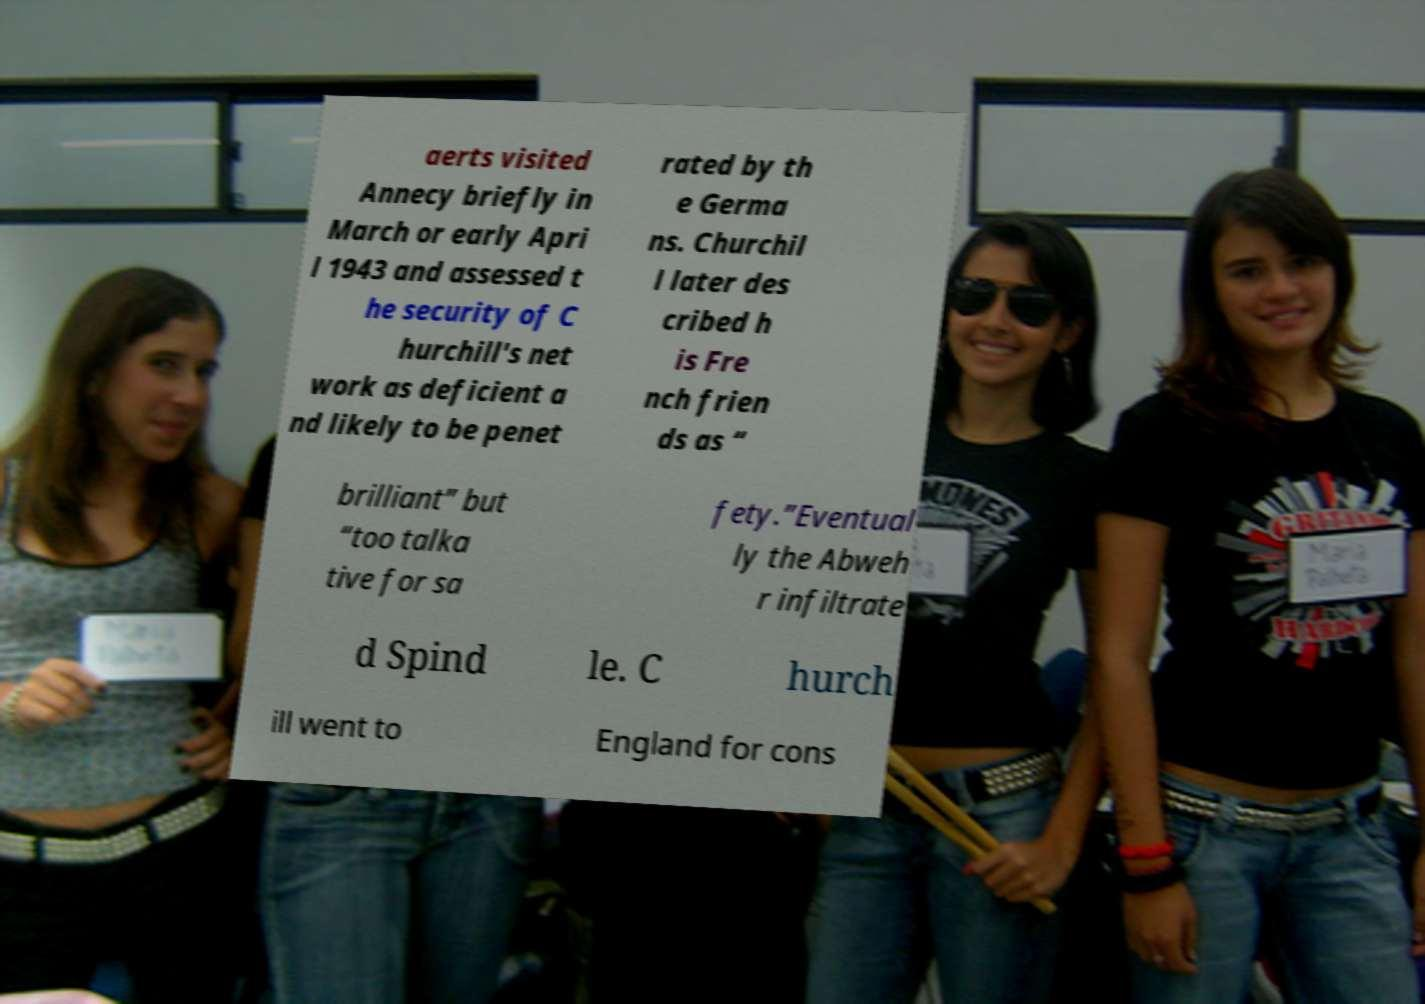What messages or text are displayed in this image? I need them in a readable, typed format. aerts visited Annecy briefly in March or early Apri l 1943 and assessed t he security of C hurchill's net work as deficient a nd likely to be penet rated by th e Germa ns. Churchil l later des cribed h is Fre nch frien ds as “ brilliant” but “too talka tive for sa fety.”Eventual ly the Abweh r infiltrate d Spind le. C hurch ill went to England for cons 